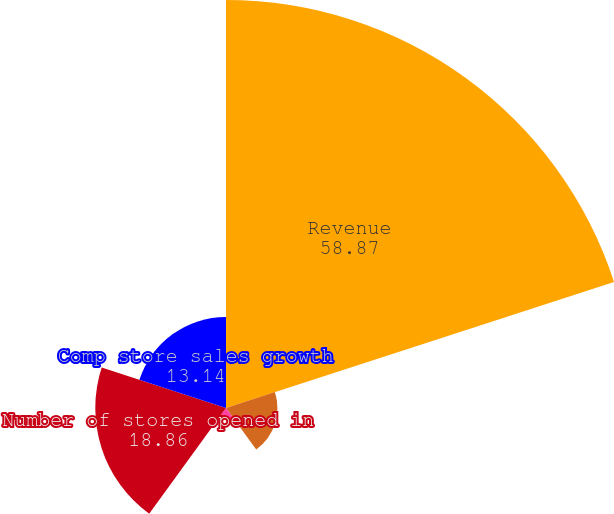Convert chart. <chart><loc_0><loc_0><loc_500><loc_500><pie_chart><fcel>Revenue<fcel>Operating income (loss)<fcel>Net income (loss)<fcel>Number of stores opened in<fcel>Comp store sales growth<nl><fcel>58.87%<fcel>7.42%<fcel>1.71%<fcel>18.86%<fcel>13.14%<nl></chart> 